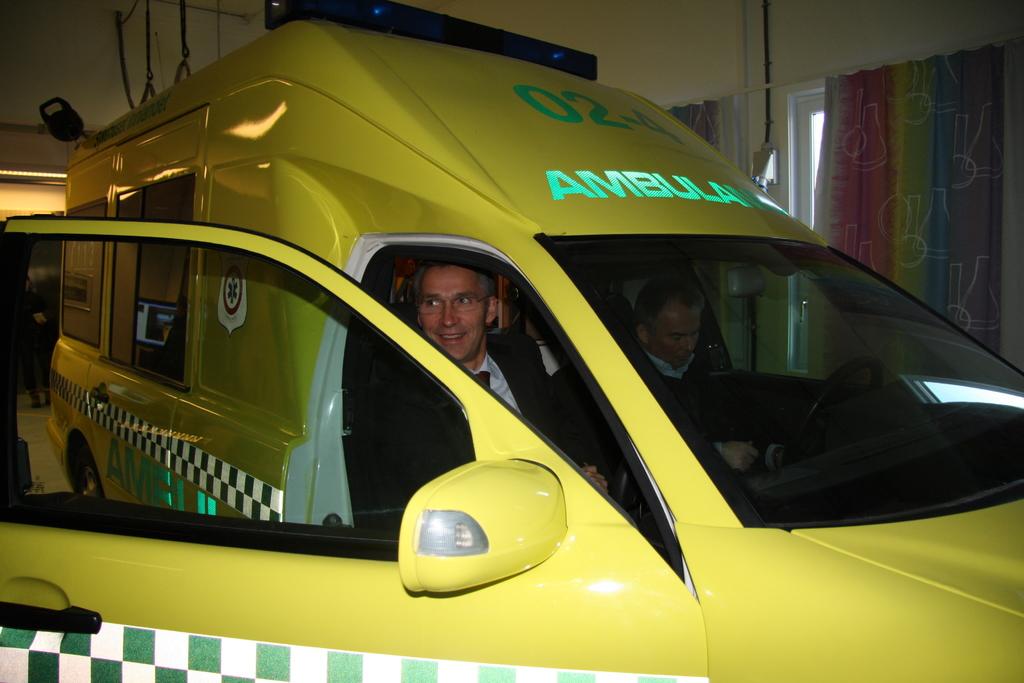What emergency service is this vehicle to be used for?
Offer a very short reply. Ambulance. What number is this vehicle?
Your answer should be compact. 02-4. 